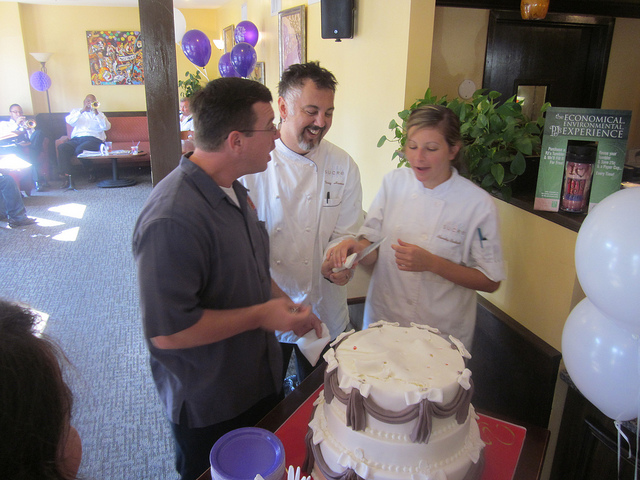Identify the text contained in this image. ECONOMICAL EXPERIENCE ENVIRONMENTAL 